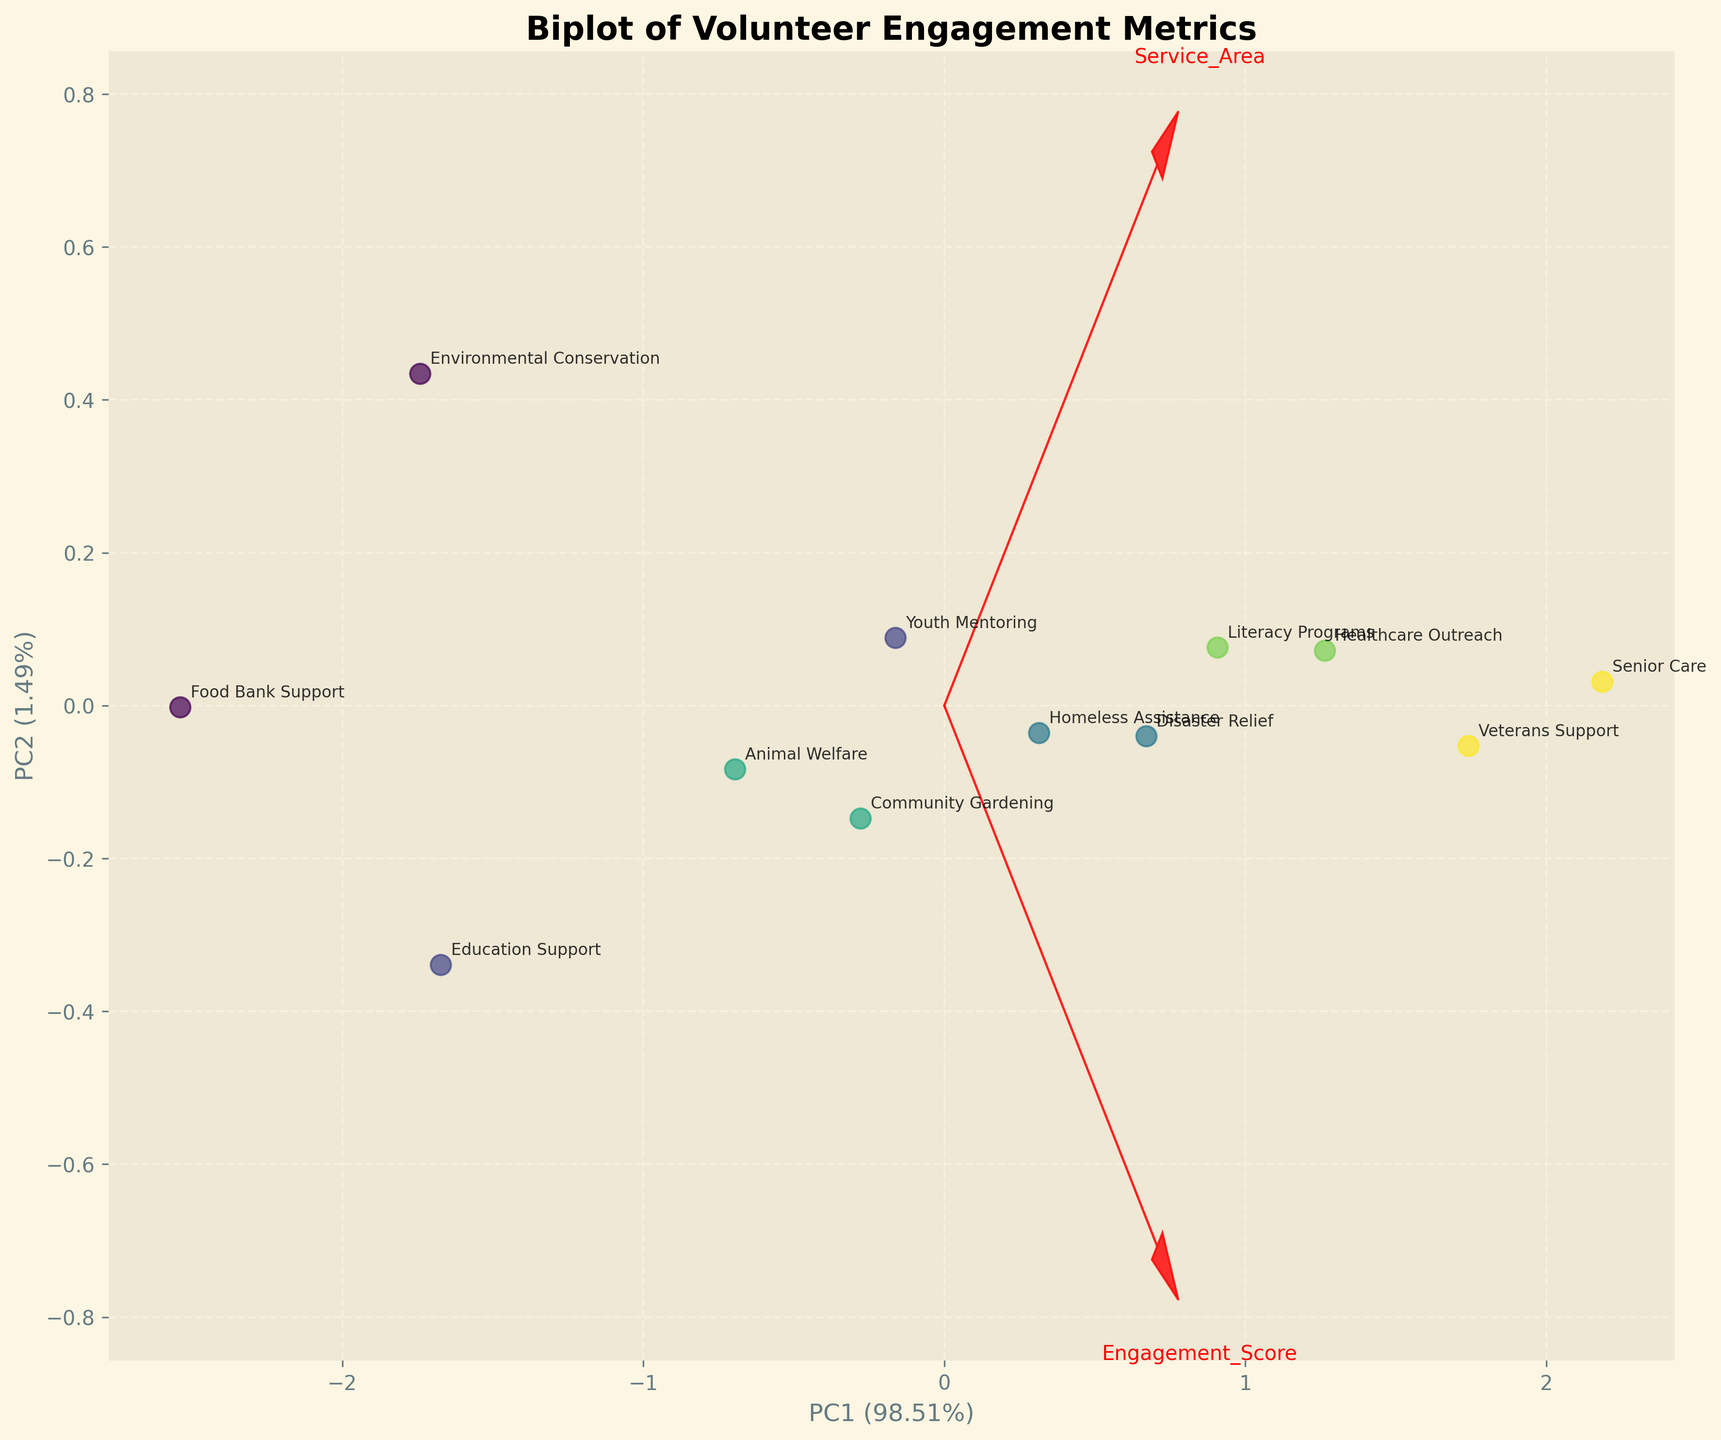What is the title of the figure? The title of the figure is usually positioned at the top. In this case, it reads "Biplot of Volunteer Engagement Metrics."
Answer: Biplot of Volunteer Engagement Metrics Which age group corresponds to the point with the highest Leadership Index? Locate the points and read the annotated Service Areas, then look for the point with the highest y-axis value, which corresponds to the Leadership Index. The point with the highest Leadership Index is for the age group 65+.
Answer: 65+ What are the labels for the x and y axes? Look at the labels on the x and y axes. They are usually indicated next to or below the axes. For this plot, the x-axis is labeled "PC1" and the y-axis is labeled "PC2" along with their respective percentages.
Answer: PC1, PC2 Which Service Area has the lowest Engagement Score? Identify the points and their Engagement Scores marked along the PCA axis. The point with the lowest value on the x-axis (PC1 axis if assumed) represents the lowest Engagement Score. The annotation shows it as "Food Bank Support."
Answer: Food Bank Support How does the Engagement Score correlate with the Leadership Index in the plot? Look at the arrows representing the feature vectors on the biplot. If the vectors for Engagement Score and Leadership Index point in a similar direction, there is a positive correlation.
Answer: Positive correlation Which age group is associated with 'Disaster Relief'? Locate the annotated Service Area "Disaster Relief" on the plot and read the corresponding age group from the color legend or the data points. The age group is 36-45.
Answer: 36-45 What is the Service Area for the age group 26-35 with the highest engagement shown on the plot? Locate the points for the age group 26-35 and compare their x-axis values for Engagement Score. "Youth Mentoring" has the highest value.
Answer: Youth Mentoring Which feature explains more variance, PC1 or PC2? Look at the axis labels, which show percentages in parentheses indicating the variance explained. PC1 or PC2 with the higher percentage explains more variance. PC1 has the higher percentage.
Answer: PC1 What does the length of the arrow represent in the biplot? The length of the arrow in the biplot typically represents the importance or contribution of the variable to the principal components.
Answer: Importance of the variable Which age groups show a Leadership Index above 6.0? Identify the points with a y-axis (PC2) value above a certain threshold that seems to represent 6.0. The associated age groups are 56-65 and 65+.
Answer: 56-65, 65+ 